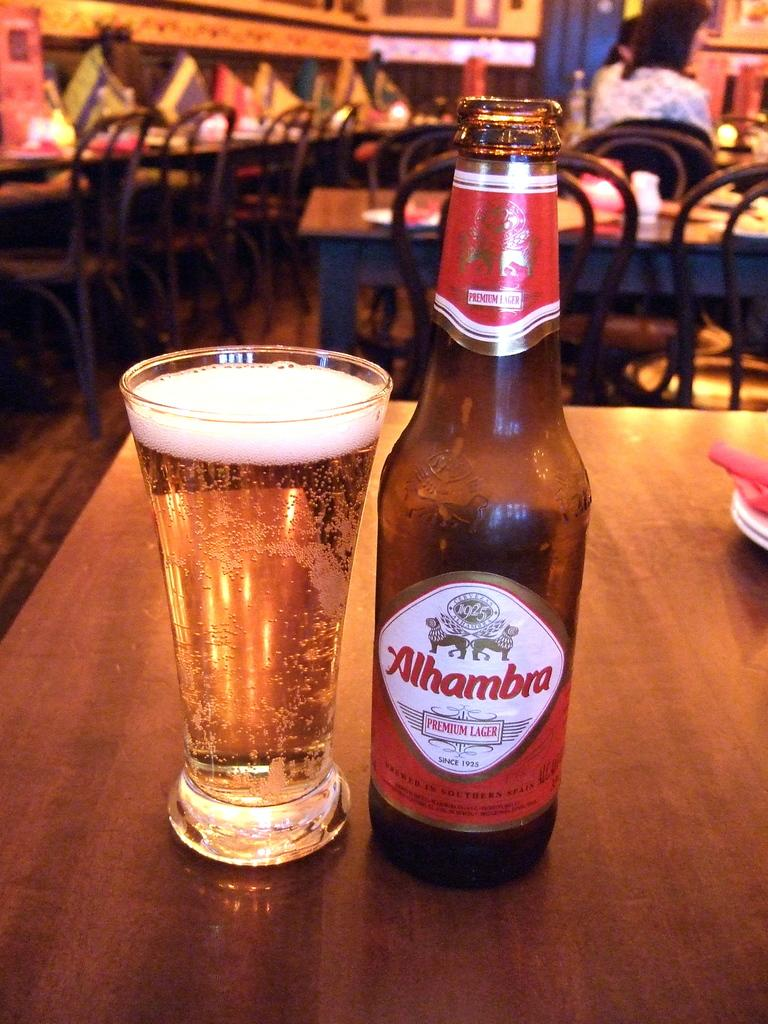<image>
Create a compact narrative representing the image presented. A bottle of Alhambra lager next to a full glass of beer on a table. 